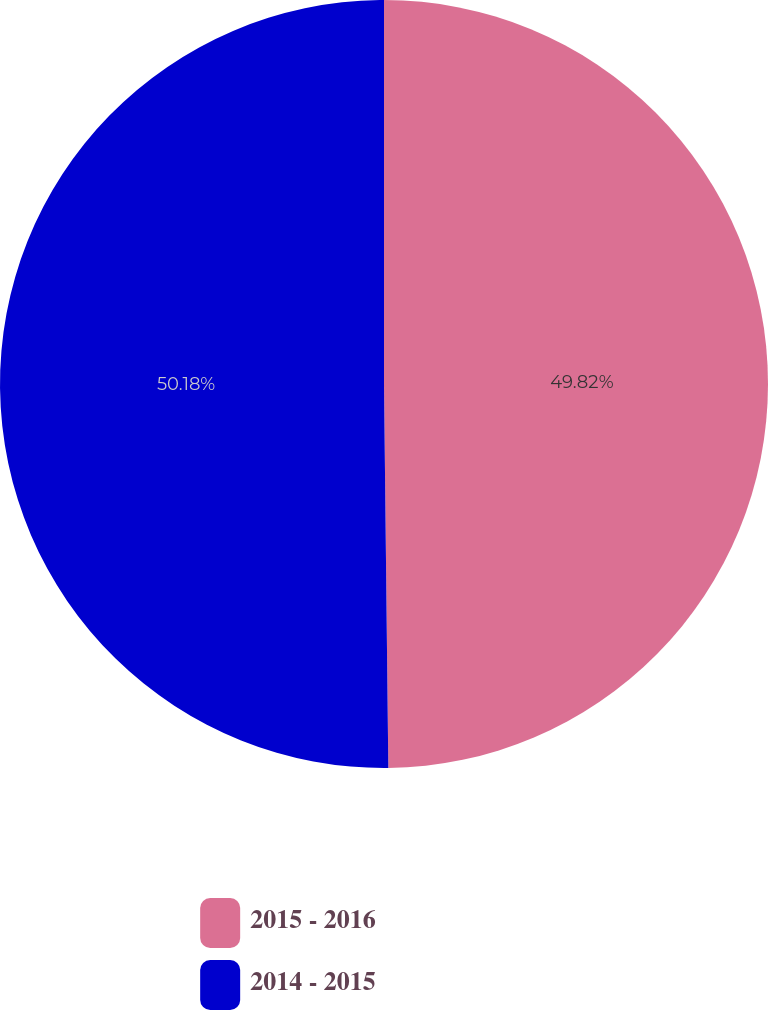Convert chart to OTSL. <chart><loc_0><loc_0><loc_500><loc_500><pie_chart><fcel>2015 - 2016<fcel>2014 - 2015<nl><fcel>49.82%<fcel>50.18%<nl></chart> 